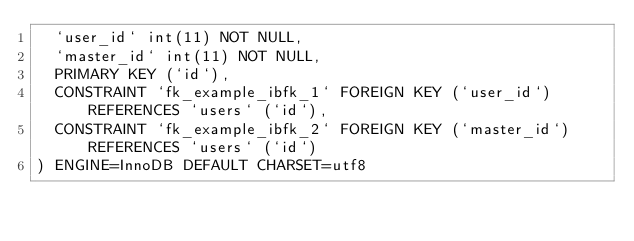Convert code to text. <code><loc_0><loc_0><loc_500><loc_500><_SQL_>  `user_id` int(11) NOT NULL,
  `master_id` int(11) NOT NULL,
  PRIMARY KEY (`id`),
  CONSTRAINT `fk_example_ibfk_1` FOREIGN KEY (`user_id`) REFERENCES `users` (`id`),
  CONSTRAINT `fk_example_ibfk_2` FOREIGN KEY (`master_id`) REFERENCES `users` (`id`)
) ENGINE=InnoDB DEFAULT CHARSET=utf8</code> 